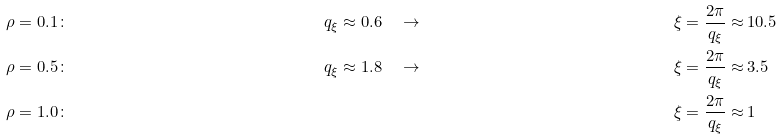Convert formula to latex. <formula><loc_0><loc_0><loc_500><loc_500>\rho = 0 . 1 & \colon & \quad q _ { \xi } \approx 0 . 6 & \quad \rightarrow \quad & \xi = \frac { 2 \pi } { q _ { \xi } } \approx & \, 1 0 . 5 \\ \rho = 0 . 5 & \colon & \quad q _ { \xi } \approx 1 . 8 & \quad \rightarrow \quad & \xi = \frac { 2 \pi } { q _ { \xi } } \approx & \, 3 . 5 \\ \rho = 1 . 0 & \colon & \quad & \quad & \xi = \frac { 2 \pi } { q _ { \xi } } \approx & \, 1</formula> 